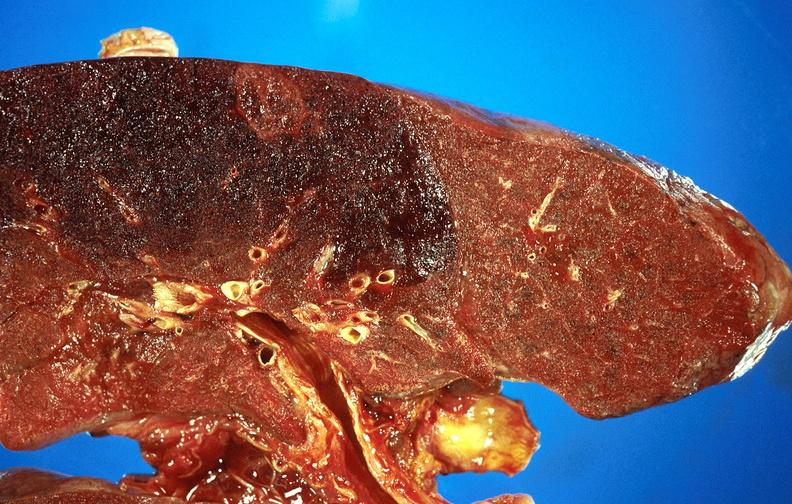what does this image show?
Answer the question using a single word or phrase. Subacute pulmonary thromboembolus with acute infarct 